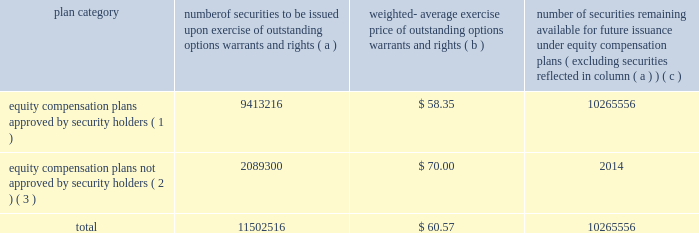Equity compensation plan information the plan documents for the plans described in the footnotes below are included as exhibits to this form 10-k , and are incorporated herein by reference in their entirety .
The table provides information as of dec .
31 , 2006 regarding the number of shares of ppg common stock that may be issued under ppg 2019s equity compensation plans .
Plan category securities exercise of outstanding options , warrants and rights weighted- average exercise price of outstanding warrants and rights number of securities remaining available for future issuance under equity compensation ( excluding securities reflected in column ( a ) ) equity compensation plans approved by security holders ( 1 ) 9413216 $ 58.35 10265556 equity compensation plans not approved by security holders ( 2 ) , ( 3 ) 2089300 $ 70.00 2014 .
( 1 ) equity compensation plans approved by security holders include the ppg industries , inc .
Stock plan , the ppg omnibus plan , the ppg industries , inc .
Executive officers 2019 long term incentive plan , and the ppg industries inc .
Long term incentive plan .
( 2 ) equity compensation plans not approved by security holders include the ppg industries , inc .
Challenge 2000 stock plan .
This plan is a broad- based stock option plan under which the company granted to substantially all active employees of the company and its majority owned subsidiaries on july 1 , 1998 , the option to purchase 100 shares of the company 2019s common stock at its then fair market value of $ 70.00 per share .
Options became exercisable on july 1 , 2003 , and expire on june 30 , 2008 .
There were 2089300 shares issuable upon exercise of options outstanding under this plan as of dec .
31 , 2006 .
( 3 ) excluded from the information presented here are common stock equivalents held under the ppg industries , inc .
Deferred compensation plan , the ppg industries , inc .
Deferred compensation plan for directors and the ppg industries , inc .
Directors 2019 common stock plan , none of which are equity compensation plans .
As supplemental information , there were 491168 common stock equivalents held under such plans as of dec .
31 , 2006 .
Item 6 .
Selected financial data the information required by item 6 regarding the selected financial data for the five years ended dec .
31 , 2006 is included in exhibit 99.2 filed with this form 10-k and is incorporated herein by reference .
This information is also reported in the eleven-year digest on page 72 of the annual report under the captions net sales , income ( loss ) before accounting changes , cumulative effect of accounting changes , net income ( loss ) , earnings ( loss ) per common share before accounting changes , cumulative effect of accounting changes on earnings ( loss ) per common share , earnings ( loss ) per common share , earnings ( loss ) per common share 2013 assuming dilution , dividends per share , total assets and long-term debt for the years 2002 through 2006 .
Item 7 .
Management 2019s discussion and analysis of financial condition and results of operations performance in 2006 compared with 2005 performance overview our sales increased 8% ( 8 % ) to $ 11.0 billion in 2006 compared to $ 10.2 billion in 2005 .
Sales increased 4% ( 4 % ) due to the impact of acquisitions , 2% ( 2 % ) due to increased volumes , and 2% ( 2 % ) due to increased selling prices .
Cost of sales as a percentage of sales increased slightly to 63.7% ( 63.7 % ) compared to 63.5% ( 63.5 % ) in 2005 .
Selling , general and administrative expense increased slightly as a percentage of sales to 17.9% ( 17.9 % ) compared to 17.4% ( 17.4 % ) in 2005 .
These costs increased primarily due to higher expenses related to store expansions in our architectural coatings operating segment and increased advertising to promote growth in our optical products operating segment .
Other charges decreased $ 81 million in 2006 .
Other charges in 2006 included pretax charges of $ 185 million for estimated environmental remediation costs at sites in new jersey and $ 42 million for legal settlements offset in part by pretax earnings of $ 44 million for insurance recoveries related to the marvin legal settlement and to hurricane rita .
Other charges in 2005 included pretax charges of $ 132 million related to the marvin legal settlement net of related insurance recoveries of $ 18 million , $ 61 million for the federal glass class action antitrust legal settlement , $ 34 million of direct costs related to the impact of hurricanes rita and katrina , $ 27 million for an asset impairment charge in our fine chemicals operating segment and $ 19 million for debt refinancing costs .
Other earnings increased $ 30 million in 2006 due to higher equity earnings , primarily from our asian fiber glass joint ventures , and higher royalty income .
Net income and earnings per share 2013 assuming dilution for 2006 were $ 711 million and $ 4.27 , respectively , compared to $ 596 million and $ 3.49 , respectively , for 2005 .
Net income in 2006 included aftertax charges of $ 106 million , or 64 cents a share , for estimated environmental remediation costs at sites in new jersey and louisiana in the third quarter ; $ 26 million , or 15 cents a share , for legal settlements ; $ 23 million , or 14 cents a share for business restructuring ; $ 17 million , or 10 cents a share , to reflect the net increase in the current value of the company 2019s obligation relating to asbestos claims under the ppg settlement arrangement ; and aftertax earnings of $ 24 million , or 14 cents a share for insurance recoveries .
Net income in 2005 included aftertax charges of $ 117 million , or 68 cents a share for legal settlements net of insurance ; $ 21 million , or 12 cents a share for direct costs related to the impact of hurricanes katrina and rita ; $ 17 million , or 10 cents a share , related to an asset impairment charge related to our fine chemicals operating segment ; $ 12 million , or 7 cents a share , for debt refinancing cost ; and $ 13 million , or 8 cents a share , to reflect the net increase in the current 2006 ppg annual report and form 10-k 19 4282_txt to be issued options , number of .
What was the change in earnings per share from 2005 to 2006? 
Computations: (4.27 - 3.49)
Answer: 0.78. 